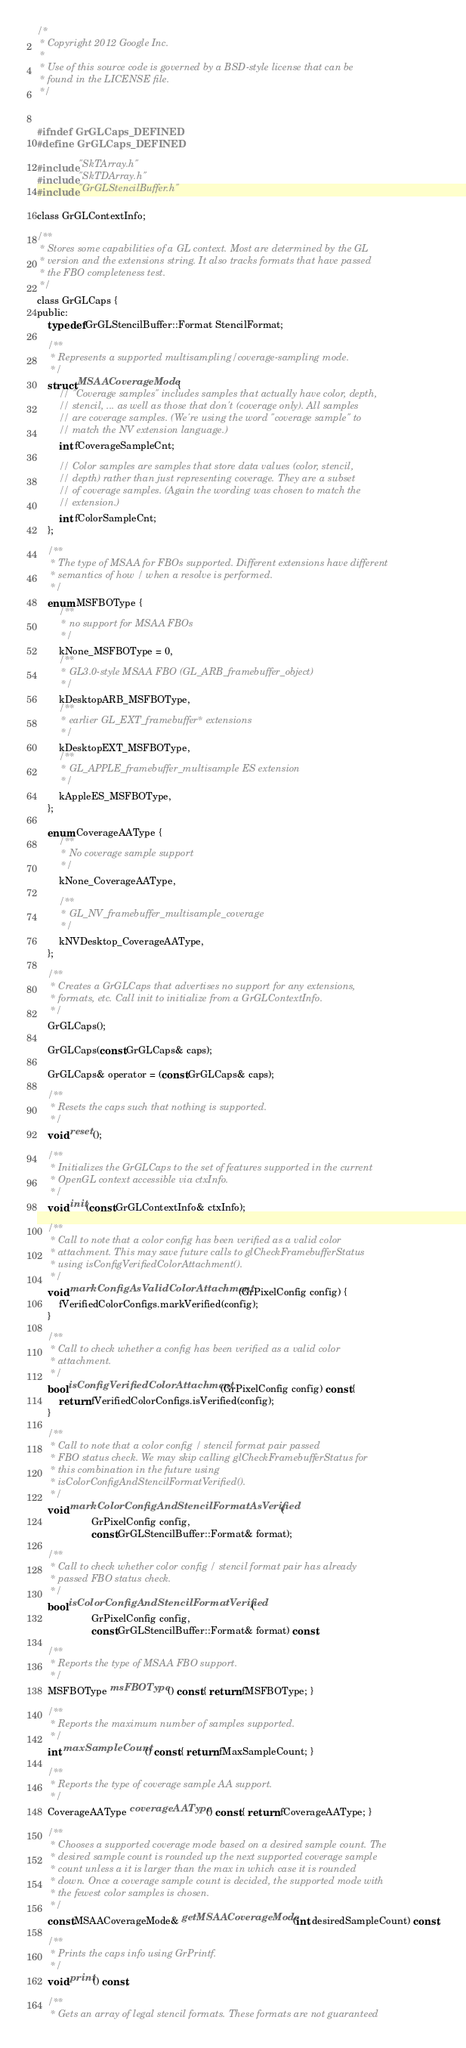Convert code to text. <code><loc_0><loc_0><loc_500><loc_500><_C_>/*
 * Copyright 2012 Google Inc.
 *
 * Use of this source code is governed by a BSD-style license that can be
 * found in the LICENSE file.
 */


#ifndef GrGLCaps_DEFINED
#define GrGLCaps_DEFINED

#include "SkTArray.h"
#include "SkTDArray.h"
#include "GrGLStencilBuffer.h"

class GrGLContextInfo;

/**
 * Stores some capabilities of a GL context. Most are determined by the GL
 * version and the extensions string. It also tracks formats that have passed
 * the FBO completeness test.
 */
class GrGLCaps {
public:
    typedef GrGLStencilBuffer::Format StencilFormat;

    /**
     * Represents a supported multisampling/coverage-sampling mode.
     */
    struct MSAACoverageMode {
        // "Coverage samples" includes samples that actually have color, depth,
        // stencil, ... as well as those that don't (coverage only). All samples
        // are coverage samples. (We're using the word "coverage sample" to
        // match the NV extension language.)
        int fCoverageSampleCnt;

        // Color samples are samples that store data values (color, stencil,
        // depth) rather than just representing coverage. They are a subset
        // of coverage samples. (Again the wording was chosen to match the
        // extension.)
        int fColorSampleCnt;
    };

    /**
     * The type of MSAA for FBOs supported. Different extensions have different
     * semantics of how / when a resolve is performed.
     */
    enum MSFBOType {
        /**
         * no support for MSAA FBOs
         */
        kNone_MSFBOType = 0,
        /**
         * GL3.0-style MSAA FBO (GL_ARB_framebuffer_object)
         */
        kDesktopARB_MSFBOType,
        /**
         * earlier GL_EXT_framebuffer* extensions
         */
        kDesktopEXT_MSFBOType,
        /**
         * GL_APPLE_framebuffer_multisample ES extension
         */
        kAppleES_MSFBOType,
    };

    enum CoverageAAType {
        /**
         * No coverage sample support
         */
        kNone_CoverageAAType,

        /**
         * GL_NV_framebuffer_multisample_coverage
         */
        kNVDesktop_CoverageAAType,
    };

    /**
     * Creates a GrGLCaps that advertises no support for any extensions,
     * formats, etc. Call init to initialize from a GrGLContextInfo.
     */
    GrGLCaps();

    GrGLCaps(const GrGLCaps& caps);

    GrGLCaps& operator = (const GrGLCaps& caps);

    /**
     * Resets the caps such that nothing is supported.
     */
    void reset();

    /**
     * Initializes the GrGLCaps to the set of features supported in the current
     * OpenGL context accessible via ctxInfo.
     */
    void init(const GrGLContextInfo& ctxInfo);

    /**
     * Call to note that a color config has been verified as a valid color
     * attachment. This may save future calls to glCheckFramebufferStatus
     * using isConfigVerifiedColorAttachment().
     */
    void markConfigAsValidColorAttachment(GrPixelConfig config) {
        fVerifiedColorConfigs.markVerified(config);
    }

    /**
     * Call to check whether a config has been verified as a valid color
     * attachment.
     */
    bool isConfigVerifiedColorAttachment(GrPixelConfig config) const {
        return fVerifiedColorConfigs.isVerified(config);
    }

    /**
     * Call to note that a color config / stencil format pair passed
     * FBO status check. We may skip calling glCheckFramebufferStatus for
     * this combination in the future using
     * isColorConfigAndStencilFormatVerified().
     */
    void markColorConfigAndStencilFormatAsVerified(
                    GrPixelConfig config,
                    const GrGLStencilBuffer::Format& format);

    /**
     * Call to check whether color config / stencil format pair has already
     * passed FBO status check.
     */
    bool isColorConfigAndStencilFormatVerified(
                    GrPixelConfig config,
                    const GrGLStencilBuffer::Format& format) const;

    /**
     * Reports the type of MSAA FBO support.
     */
    MSFBOType msFBOType() const { return fMSFBOType; }

    /**
     * Reports the maximum number of samples supported.
     */
    int maxSampleCount() const { return fMaxSampleCount; }

    /**
     * Reports the type of coverage sample AA support.
     */
    CoverageAAType coverageAAType() const { return fCoverageAAType; }

    /**
     * Chooses a supported coverage mode based on a desired sample count. The
     * desired sample count is rounded up the next supported coverage sample
     * count unless a it is larger than the max in which case it is rounded
     * down. Once a coverage sample count is decided, the supported mode with
     * the fewest color samples is chosen.
     */
    const MSAACoverageMode& getMSAACoverageMode(int desiredSampleCount) const;

    /**
     * Prints the caps info using GrPrintf.
     */
    void print() const;

    /**
     * Gets an array of legal stencil formats. These formats are not guaranteed</code> 